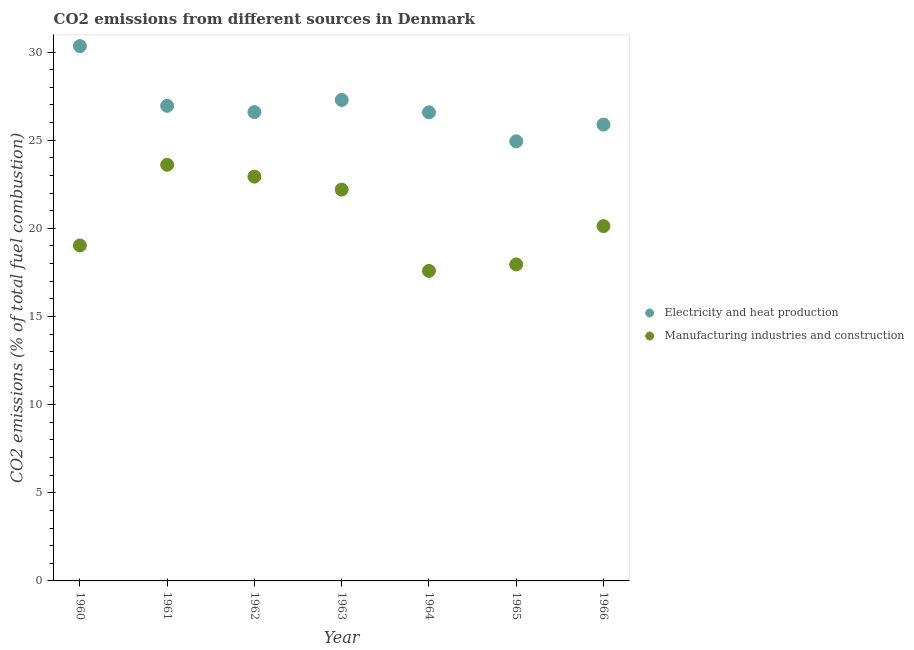How many different coloured dotlines are there?
Provide a succinct answer. 2. Is the number of dotlines equal to the number of legend labels?
Your response must be concise. Yes. What is the co2 emissions due to manufacturing industries in 1962?
Your answer should be very brief. 22.93. Across all years, what is the maximum co2 emissions due to manufacturing industries?
Keep it short and to the point. 23.6. Across all years, what is the minimum co2 emissions due to manufacturing industries?
Offer a terse response. 17.59. In which year was the co2 emissions due to manufacturing industries maximum?
Provide a succinct answer. 1961. In which year was the co2 emissions due to electricity and heat production minimum?
Make the answer very short. 1965. What is the total co2 emissions due to manufacturing industries in the graph?
Offer a terse response. 143.42. What is the difference between the co2 emissions due to electricity and heat production in 1961 and that in 1965?
Offer a very short reply. 2.01. What is the difference between the co2 emissions due to manufacturing industries in 1965 and the co2 emissions due to electricity and heat production in 1964?
Your answer should be very brief. -8.63. What is the average co2 emissions due to manufacturing industries per year?
Provide a short and direct response. 20.49. In the year 1966, what is the difference between the co2 emissions due to electricity and heat production and co2 emissions due to manufacturing industries?
Keep it short and to the point. 5.76. In how many years, is the co2 emissions due to electricity and heat production greater than 27 %?
Your answer should be compact. 2. What is the ratio of the co2 emissions due to electricity and heat production in 1960 to that in 1965?
Make the answer very short. 1.22. What is the difference between the highest and the second highest co2 emissions due to manufacturing industries?
Ensure brevity in your answer.  0.67. What is the difference between the highest and the lowest co2 emissions due to manufacturing industries?
Make the answer very short. 6.02. In how many years, is the co2 emissions due to manufacturing industries greater than the average co2 emissions due to manufacturing industries taken over all years?
Offer a terse response. 3. Does the co2 emissions due to manufacturing industries monotonically increase over the years?
Give a very brief answer. No. Is the co2 emissions due to electricity and heat production strictly greater than the co2 emissions due to manufacturing industries over the years?
Your answer should be very brief. Yes. Is the co2 emissions due to electricity and heat production strictly less than the co2 emissions due to manufacturing industries over the years?
Offer a terse response. No. Are the values on the major ticks of Y-axis written in scientific E-notation?
Ensure brevity in your answer.  No. Does the graph contain grids?
Provide a short and direct response. No. How many legend labels are there?
Your answer should be compact. 2. What is the title of the graph?
Make the answer very short. CO2 emissions from different sources in Denmark. What is the label or title of the X-axis?
Offer a very short reply. Year. What is the label or title of the Y-axis?
Offer a very short reply. CO2 emissions (% of total fuel combustion). What is the CO2 emissions (% of total fuel combustion) in Electricity and heat production in 1960?
Your answer should be very brief. 30.34. What is the CO2 emissions (% of total fuel combustion) in Manufacturing industries and construction in 1960?
Keep it short and to the point. 19.03. What is the CO2 emissions (% of total fuel combustion) in Electricity and heat production in 1961?
Keep it short and to the point. 26.95. What is the CO2 emissions (% of total fuel combustion) in Manufacturing industries and construction in 1961?
Keep it short and to the point. 23.6. What is the CO2 emissions (% of total fuel combustion) of Electricity and heat production in 1962?
Provide a short and direct response. 26.59. What is the CO2 emissions (% of total fuel combustion) in Manufacturing industries and construction in 1962?
Ensure brevity in your answer.  22.93. What is the CO2 emissions (% of total fuel combustion) in Electricity and heat production in 1963?
Your answer should be very brief. 27.28. What is the CO2 emissions (% of total fuel combustion) of Manufacturing industries and construction in 1963?
Your answer should be compact. 22.2. What is the CO2 emissions (% of total fuel combustion) in Electricity and heat production in 1964?
Your response must be concise. 26.58. What is the CO2 emissions (% of total fuel combustion) of Manufacturing industries and construction in 1964?
Provide a short and direct response. 17.59. What is the CO2 emissions (% of total fuel combustion) of Electricity and heat production in 1965?
Make the answer very short. 24.94. What is the CO2 emissions (% of total fuel combustion) of Manufacturing industries and construction in 1965?
Offer a very short reply. 17.95. What is the CO2 emissions (% of total fuel combustion) of Electricity and heat production in 1966?
Your answer should be compact. 25.88. What is the CO2 emissions (% of total fuel combustion) in Manufacturing industries and construction in 1966?
Your answer should be compact. 20.13. Across all years, what is the maximum CO2 emissions (% of total fuel combustion) of Electricity and heat production?
Make the answer very short. 30.34. Across all years, what is the maximum CO2 emissions (% of total fuel combustion) of Manufacturing industries and construction?
Offer a terse response. 23.6. Across all years, what is the minimum CO2 emissions (% of total fuel combustion) in Electricity and heat production?
Offer a terse response. 24.94. Across all years, what is the minimum CO2 emissions (% of total fuel combustion) in Manufacturing industries and construction?
Offer a terse response. 17.59. What is the total CO2 emissions (% of total fuel combustion) in Electricity and heat production in the graph?
Keep it short and to the point. 188.56. What is the total CO2 emissions (% of total fuel combustion) in Manufacturing industries and construction in the graph?
Provide a short and direct response. 143.42. What is the difference between the CO2 emissions (% of total fuel combustion) in Electricity and heat production in 1960 and that in 1961?
Your response must be concise. 3.39. What is the difference between the CO2 emissions (% of total fuel combustion) of Manufacturing industries and construction in 1960 and that in 1961?
Your response must be concise. -4.57. What is the difference between the CO2 emissions (% of total fuel combustion) of Electricity and heat production in 1960 and that in 1962?
Make the answer very short. 3.74. What is the difference between the CO2 emissions (% of total fuel combustion) of Manufacturing industries and construction in 1960 and that in 1962?
Your answer should be very brief. -3.9. What is the difference between the CO2 emissions (% of total fuel combustion) in Electricity and heat production in 1960 and that in 1963?
Make the answer very short. 3.05. What is the difference between the CO2 emissions (% of total fuel combustion) of Manufacturing industries and construction in 1960 and that in 1963?
Make the answer very short. -3.17. What is the difference between the CO2 emissions (% of total fuel combustion) of Electricity and heat production in 1960 and that in 1964?
Give a very brief answer. 3.76. What is the difference between the CO2 emissions (% of total fuel combustion) in Manufacturing industries and construction in 1960 and that in 1964?
Keep it short and to the point. 1.44. What is the difference between the CO2 emissions (% of total fuel combustion) in Electricity and heat production in 1960 and that in 1965?
Offer a very short reply. 5.4. What is the difference between the CO2 emissions (% of total fuel combustion) in Manufacturing industries and construction in 1960 and that in 1965?
Offer a very short reply. 1.08. What is the difference between the CO2 emissions (% of total fuel combustion) in Electricity and heat production in 1960 and that in 1966?
Provide a succinct answer. 4.45. What is the difference between the CO2 emissions (% of total fuel combustion) in Manufacturing industries and construction in 1960 and that in 1966?
Offer a very short reply. -1.1. What is the difference between the CO2 emissions (% of total fuel combustion) of Electricity and heat production in 1961 and that in 1962?
Your response must be concise. 0.35. What is the difference between the CO2 emissions (% of total fuel combustion) in Manufacturing industries and construction in 1961 and that in 1962?
Offer a terse response. 0.67. What is the difference between the CO2 emissions (% of total fuel combustion) of Electricity and heat production in 1961 and that in 1963?
Make the answer very short. -0.33. What is the difference between the CO2 emissions (% of total fuel combustion) of Manufacturing industries and construction in 1961 and that in 1963?
Keep it short and to the point. 1.41. What is the difference between the CO2 emissions (% of total fuel combustion) in Electricity and heat production in 1961 and that in 1964?
Your response must be concise. 0.37. What is the difference between the CO2 emissions (% of total fuel combustion) of Manufacturing industries and construction in 1961 and that in 1964?
Your answer should be very brief. 6.02. What is the difference between the CO2 emissions (% of total fuel combustion) in Electricity and heat production in 1961 and that in 1965?
Make the answer very short. 2.01. What is the difference between the CO2 emissions (% of total fuel combustion) of Manufacturing industries and construction in 1961 and that in 1965?
Provide a succinct answer. 5.65. What is the difference between the CO2 emissions (% of total fuel combustion) of Electricity and heat production in 1961 and that in 1966?
Ensure brevity in your answer.  1.07. What is the difference between the CO2 emissions (% of total fuel combustion) of Manufacturing industries and construction in 1961 and that in 1966?
Your answer should be very brief. 3.48. What is the difference between the CO2 emissions (% of total fuel combustion) of Electricity and heat production in 1962 and that in 1963?
Make the answer very short. -0.69. What is the difference between the CO2 emissions (% of total fuel combustion) of Manufacturing industries and construction in 1962 and that in 1963?
Provide a succinct answer. 0.73. What is the difference between the CO2 emissions (% of total fuel combustion) of Electricity and heat production in 1962 and that in 1964?
Provide a succinct answer. 0.02. What is the difference between the CO2 emissions (% of total fuel combustion) in Manufacturing industries and construction in 1962 and that in 1964?
Keep it short and to the point. 5.35. What is the difference between the CO2 emissions (% of total fuel combustion) of Electricity and heat production in 1962 and that in 1965?
Your answer should be very brief. 1.66. What is the difference between the CO2 emissions (% of total fuel combustion) of Manufacturing industries and construction in 1962 and that in 1965?
Keep it short and to the point. 4.98. What is the difference between the CO2 emissions (% of total fuel combustion) in Electricity and heat production in 1962 and that in 1966?
Provide a short and direct response. 0.71. What is the difference between the CO2 emissions (% of total fuel combustion) of Manufacturing industries and construction in 1962 and that in 1966?
Provide a short and direct response. 2.8. What is the difference between the CO2 emissions (% of total fuel combustion) in Electricity and heat production in 1963 and that in 1964?
Offer a very short reply. 0.7. What is the difference between the CO2 emissions (% of total fuel combustion) in Manufacturing industries and construction in 1963 and that in 1964?
Offer a very short reply. 4.61. What is the difference between the CO2 emissions (% of total fuel combustion) of Electricity and heat production in 1963 and that in 1965?
Your response must be concise. 2.35. What is the difference between the CO2 emissions (% of total fuel combustion) in Manufacturing industries and construction in 1963 and that in 1965?
Provide a succinct answer. 4.24. What is the difference between the CO2 emissions (% of total fuel combustion) of Electricity and heat production in 1963 and that in 1966?
Provide a succinct answer. 1.4. What is the difference between the CO2 emissions (% of total fuel combustion) of Manufacturing industries and construction in 1963 and that in 1966?
Your answer should be very brief. 2.07. What is the difference between the CO2 emissions (% of total fuel combustion) in Electricity and heat production in 1964 and that in 1965?
Your answer should be very brief. 1.64. What is the difference between the CO2 emissions (% of total fuel combustion) of Manufacturing industries and construction in 1964 and that in 1965?
Make the answer very short. -0.37. What is the difference between the CO2 emissions (% of total fuel combustion) of Electricity and heat production in 1964 and that in 1966?
Provide a succinct answer. 0.69. What is the difference between the CO2 emissions (% of total fuel combustion) in Manufacturing industries and construction in 1964 and that in 1966?
Provide a succinct answer. -2.54. What is the difference between the CO2 emissions (% of total fuel combustion) of Electricity and heat production in 1965 and that in 1966?
Offer a terse response. -0.95. What is the difference between the CO2 emissions (% of total fuel combustion) of Manufacturing industries and construction in 1965 and that in 1966?
Make the answer very short. -2.17. What is the difference between the CO2 emissions (% of total fuel combustion) in Electricity and heat production in 1960 and the CO2 emissions (% of total fuel combustion) in Manufacturing industries and construction in 1961?
Offer a terse response. 6.73. What is the difference between the CO2 emissions (% of total fuel combustion) of Electricity and heat production in 1960 and the CO2 emissions (% of total fuel combustion) of Manufacturing industries and construction in 1962?
Keep it short and to the point. 7.41. What is the difference between the CO2 emissions (% of total fuel combustion) in Electricity and heat production in 1960 and the CO2 emissions (% of total fuel combustion) in Manufacturing industries and construction in 1963?
Your response must be concise. 8.14. What is the difference between the CO2 emissions (% of total fuel combustion) of Electricity and heat production in 1960 and the CO2 emissions (% of total fuel combustion) of Manufacturing industries and construction in 1964?
Offer a very short reply. 12.75. What is the difference between the CO2 emissions (% of total fuel combustion) in Electricity and heat production in 1960 and the CO2 emissions (% of total fuel combustion) in Manufacturing industries and construction in 1965?
Provide a succinct answer. 12.38. What is the difference between the CO2 emissions (% of total fuel combustion) of Electricity and heat production in 1960 and the CO2 emissions (% of total fuel combustion) of Manufacturing industries and construction in 1966?
Your answer should be compact. 10.21. What is the difference between the CO2 emissions (% of total fuel combustion) of Electricity and heat production in 1961 and the CO2 emissions (% of total fuel combustion) of Manufacturing industries and construction in 1962?
Your answer should be compact. 4.02. What is the difference between the CO2 emissions (% of total fuel combustion) in Electricity and heat production in 1961 and the CO2 emissions (% of total fuel combustion) in Manufacturing industries and construction in 1963?
Offer a very short reply. 4.75. What is the difference between the CO2 emissions (% of total fuel combustion) in Electricity and heat production in 1961 and the CO2 emissions (% of total fuel combustion) in Manufacturing industries and construction in 1964?
Your answer should be very brief. 9.36. What is the difference between the CO2 emissions (% of total fuel combustion) in Electricity and heat production in 1961 and the CO2 emissions (% of total fuel combustion) in Manufacturing industries and construction in 1965?
Make the answer very short. 9. What is the difference between the CO2 emissions (% of total fuel combustion) of Electricity and heat production in 1961 and the CO2 emissions (% of total fuel combustion) of Manufacturing industries and construction in 1966?
Provide a succinct answer. 6.82. What is the difference between the CO2 emissions (% of total fuel combustion) of Electricity and heat production in 1962 and the CO2 emissions (% of total fuel combustion) of Manufacturing industries and construction in 1963?
Your answer should be compact. 4.4. What is the difference between the CO2 emissions (% of total fuel combustion) of Electricity and heat production in 1962 and the CO2 emissions (% of total fuel combustion) of Manufacturing industries and construction in 1964?
Your answer should be very brief. 9.01. What is the difference between the CO2 emissions (% of total fuel combustion) in Electricity and heat production in 1962 and the CO2 emissions (% of total fuel combustion) in Manufacturing industries and construction in 1965?
Offer a very short reply. 8.64. What is the difference between the CO2 emissions (% of total fuel combustion) in Electricity and heat production in 1962 and the CO2 emissions (% of total fuel combustion) in Manufacturing industries and construction in 1966?
Make the answer very short. 6.47. What is the difference between the CO2 emissions (% of total fuel combustion) in Electricity and heat production in 1963 and the CO2 emissions (% of total fuel combustion) in Manufacturing industries and construction in 1964?
Offer a terse response. 9.7. What is the difference between the CO2 emissions (% of total fuel combustion) in Electricity and heat production in 1963 and the CO2 emissions (% of total fuel combustion) in Manufacturing industries and construction in 1965?
Your answer should be compact. 9.33. What is the difference between the CO2 emissions (% of total fuel combustion) in Electricity and heat production in 1963 and the CO2 emissions (% of total fuel combustion) in Manufacturing industries and construction in 1966?
Provide a short and direct response. 7.16. What is the difference between the CO2 emissions (% of total fuel combustion) of Electricity and heat production in 1964 and the CO2 emissions (% of total fuel combustion) of Manufacturing industries and construction in 1965?
Provide a succinct answer. 8.63. What is the difference between the CO2 emissions (% of total fuel combustion) in Electricity and heat production in 1964 and the CO2 emissions (% of total fuel combustion) in Manufacturing industries and construction in 1966?
Provide a short and direct response. 6.45. What is the difference between the CO2 emissions (% of total fuel combustion) in Electricity and heat production in 1965 and the CO2 emissions (% of total fuel combustion) in Manufacturing industries and construction in 1966?
Provide a succinct answer. 4.81. What is the average CO2 emissions (% of total fuel combustion) in Electricity and heat production per year?
Ensure brevity in your answer.  26.94. What is the average CO2 emissions (% of total fuel combustion) in Manufacturing industries and construction per year?
Offer a very short reply. 20.49. In the year 1960, what is the difference between the CO2 emissions (% of total fuel combustion) in Electricity and heat production and CO2 emissions (% of total fuel combustion) in Manufacturing industries and construction?
Ensure brevity in your answer.  11.31. In the year 1961, what is the difference between the CO2 emissions (% of total fuel combustion) of Electricity and heat production and CO2 emissions (% of total fuel combustion) of Manufacturing industries and construction?
Offer a terse response. 3.34. In the year 1962, what is the difference between the CO2 emissions (% of total fuel combustion) of Electricity and heat production and CO2 emissions (% of total fuel combustion) of Manufacturing industries and construction?
Your answer should be compact. 3.66. In the year 1963, what is the difference between the CO2 emissions (% of total fuel combustion) of Electricity and heat production and CO2 emissions (% of total fuel combustion) of Manufacturing industries and construction?
Your response must be concise. 5.09. In the year 1964, what is the difference between the CO2 emissions (% of total fuel combustion) of Electricity and heat production and CO2 emissions (% of total fuel combustion) of Manufacturing industries and construction?
Ensure brevity in your answer.  8.99. In the year 1965, what is the difference between the CO2 emissions (% of total fuel combustion) of Electricity and heat production and CO2 emissions (% of total fuel combustion) of Manufacturing industries and construction?
Offer a very short reply. 6.98. In the year 1966, what is the difference between the CO2 emissions (% of total fuel combustion) of Electricity and heat production and CO2 emissions (% of total fuel combustion) of Manufacturing industries and construction?
Make the answer very short. 5.76. What is the ratio of the CO2 emissions (% of total fuel combustion) in Electricity and heat production in 1960 to that in 1961?
Your answer should be very brief. 1.13. What is the ratio of the CO2 emissions (% of total fuel combustion) of Manufacturing industries and construction in 1960 to that in 1961?
Provide a short and direct response. 0.81. What is the ratio of the CO2 emissions (% of total fuel combustion) in Electricity and heat production in 1960 to that in 1962?
Keep it short and to the point. 1.14. What is the ratio of the CO2 emissions (% of total fuel combustion) in Manufacturing industries and construction in 1960 to that in 1962?
Offer a terse response. 0.83. What is the ratio of the CO2 emissions (% of total fuel combustion) in Electricity and heat production in 1960 to that in 1963?
Keep it short and to the point. 1.11. What is the ratio of the CO2 emissions (% of total fuel combustion) in Manufacturing industries and construction in 1960 to that in 1963?
Keep it short and to the point. 0.86. What is the ratio of the CO2 emissions (% of total fuel combustion) in Electricity and heat production in 1960 to that in 1964?
Offer a terse response. 1.14. What is the ratio of the CO2 emissions (% of total fuel combustion) in Manufacturing industries and construction in 1960 to that in 1964?
Your answer should be compact. 1.08. What is the ratio of the CO2 emissions (% of total fuel combustion) of Electricity and heat production in 1960 to that in 1965?
Provide a succinct answer. 1.22. What is the ratio of the CO2 emissions (% of total fuel combustion) of Manufacturing industries and construction in 1960 to that in 1965?
Your response must be concise. 1.06. What is the ratio of the CO2 emissions (% of total fuel combustion) in Electricity and heat production in 1960 to that in 1966?
Make the answer very short. 1.17. What is the ratio of the CO2 emissions (% of total fuel combustion) of Manufacturing industries and construction in 1960 to that in 1966?
Your response must be concise. 0.95. What is the ratio of the CO2 emissions (% of total fuel combustion) of Electricity and heat production in 1961 to that in 1962?
Offer a terse response. 1.01. What is the ratio of the CO2 emissions (% of total fuel combustion) of Manufacturing industries and construction in 1961 to that in 1962?
Give a very brief answer. 1.03. What is the ratio of the CO2 emissions (% of total fuel combustion) of Electricity and heat production in 1961 to that in 1963?
Make the answer very short. 0.99. What is the ratio of the CO2 emissions (% of total fuel combustion) of Manufacturing industries and construction in 1961 to that in 1963?
Ensure brevity in your answer.  1.06. What is the ratio of the CO2 emissions (% of total fuel combustion) of Electricity and heat production in 1961 to that in 1964?
Make the answer very short. 1.01. What is the ratio of the CO2 emissions (% of total fuel combustion) of Manufacturing industries and construction in 1961 to that in 1964?
Your answer should be compact. 1.34. What is the ratio of the CO2 emissions (% of total fuel combustion) of Electricity and heat production in 1961 to that in 1965?
Provide a short and direct response. 1.08. What is the ratio of the CO2 emissions (% of total fuel combustion) in Manufacturing industries and construction in 1961 to that in 1965?
Ensure brevity in your answer.  1.31. What is the ratio of the CO2 emissions (% of total fuel combustion) in Electricity and heat production in 1961 to that in 1966?
Ensure brevity in your answer.  1.04. What is the ratio of the CO2 emissions (% of total fuel combustion) in Manufacturing industries and construction in 1961 to that in 1966?
Offer a very short reply. 1.17. What is the ratio of the CO2 emissions (% of total fuel combustion) in Electricity and heat production in 1962 to that in 1963?
Provide a short and direct response. 0.97. What is the ratio of the CO2 emissions (% of total fuel combustion) in Manufacturing industries and construction in 1962 to that in 1963?
Your answer should be compact. 1.03. What is the ratio of the CO2 emissions (% of total fuel combustion) in Electricity and heat production in 1962 to that in 1964?
Your answer should be compact. 1. What is the ratio of the CO2 emissions (% of total fuel combustion) in Manufacturing industries and construction in 1962 to that in 1964?
Keep it short and to the point. 1.3. What is the ratio of the CO2 emissions (% of total fuel combustion) in Electricity and heat production in 1962 to that in 1965?
Your answer should be very brief. 1.07. What is the ratio of the CO2 emissions (% of total fuel combustion) in Manufacturing industries and construction in 1962 to that in 1965?
Give a very brief answer. 1.28. What is the ratio of the CO2 emissions (% of total fuel combustion) in Electricity and heat production in 1962 to that in 1966?
Your response must be concise. 1.03. What is the ratio of the CO2 emissions (% of total fuel combustion) of Manufacturing industries and construction in 1962 to that in 1966?
Your response must be concise. 1.14. What is the ratio of the CO2 emissions (% of total fuel combustion) of Electricity and heat production in 1963 to that in 1964?
Give a very brief answer. 1.03. What is the ratio of the CO2 emissions (% of total fuel combustion) of Manufacturing industries and construction in 1963 to that in 1964?
Your answer should be compact. 1.26. What is the ratio of the CO2 emissions (% of total fuel combustion) in Electricity and heat production in 1963 to that in 1965?
Your answer should be very brief. 1.09. What is the ratio of the CO2 emissions (% of total fuel combustion) in Manufacturing industries and construction in 1963 to that in 1965?
Your answer should be very brief. 1.24. What is the ratio of the CO2 emissions (% of total fuel combustion) in Electricity and heat production in 1963 to that in 1966?
Ensure brevity in your answer.  1.05. What is the ratio of the CO2 emissions (% of total fuel combustion) in Manufacturing industries and construction in 1963 to that in 1966?
Give a very brief answer. 1.1. What is the ratio of the CO2 emissions (% of total fuel combustion) in Electricity and heat production in 1964 to that in 1965?
Provide a succinct answer. 1.07. What is the ratio of the CO2 emissions (% of total fuel combustion) of Manufacturing industries and construction in 1964 to that in 1965?
Provide a succinct answer. 0.98. What is the ratio of the CO2 emissions (% of total fuel combustion) of Electricity and heat production in 1964 to that in 1966?
Your response must be concise. 1.03. What is the ratio of the CO2 emissions (% of total fuel combustion) of Manufacturing industries and construction in 1964 to that in 1966?
Offer a terse response. 0.87. What is the ratio of the CO2 emissions (% of total fuel combustion) in Electricity and heat production in 1965 to that in 1966?
Ensure brevity in your answer.  0.96. What is the ratio of the CO2 emissions (% of total fuel combustion) in Manufacturing industries and construction in 1965 to that in 1966?
Your answer should be very brief. 0.89. What is the difference between the highest and the second highest CO2 emissions (% of total fuel combustion) in Electricity and heat production?
Ensure brevity in your answer.  3.05. What is the difference between the highest and the second highest CO2 emissions (% of total fuel combustion) of Manufacturing industries and construction?
Your answer should be compact. 0.67. What is the difference between the highest and the lowest CO2 emissions (% of total fuel combustion) in Electricity and heat production?
Ensure brevity in your answer.  5.4. What is the difference between the highest and the lowest CO2 emissions (% of total fuel combustion) of Manufacturing industries and construction?
Provide a short and direct response. 6.02. 